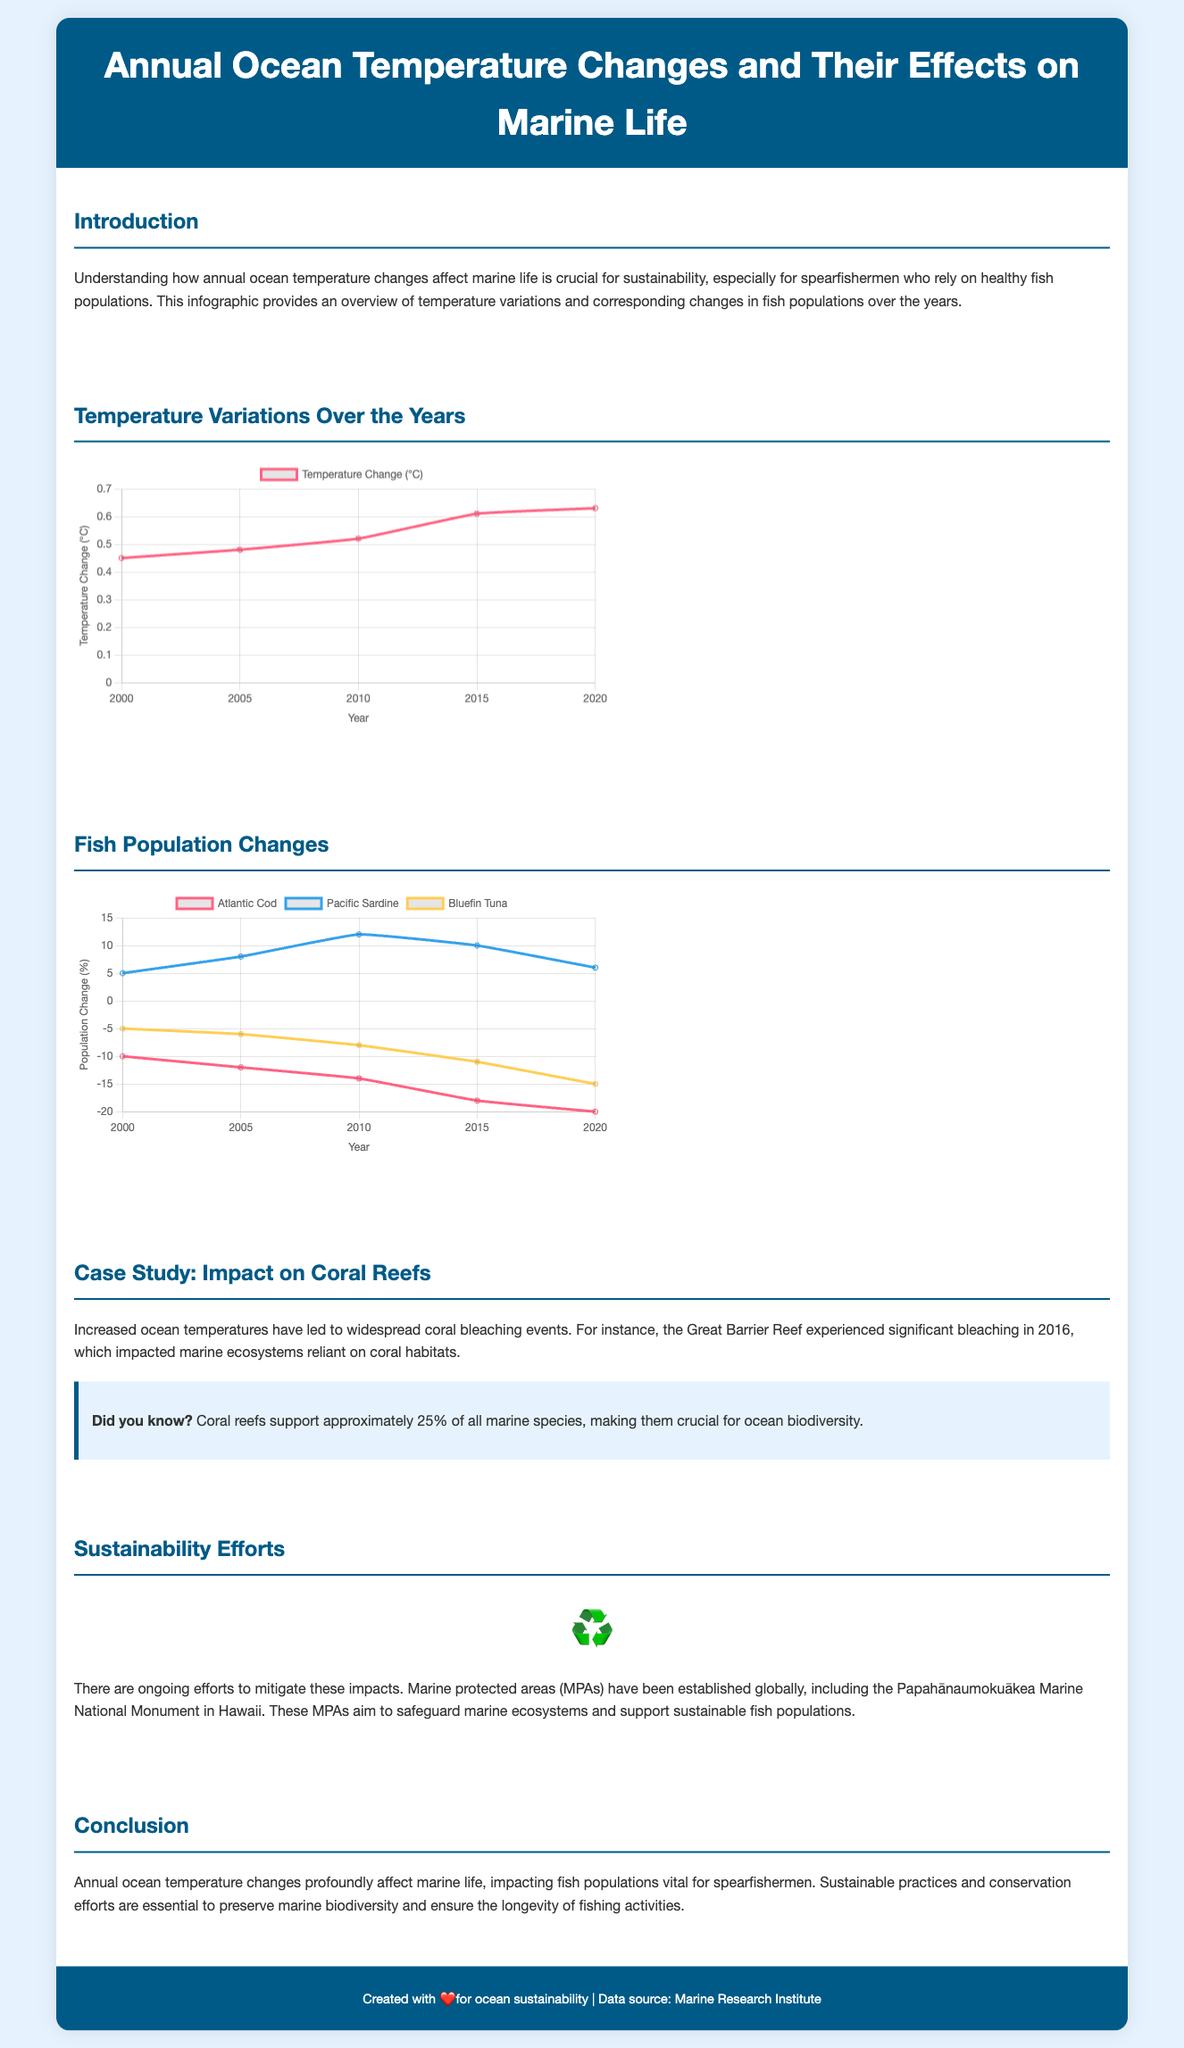What is the title of the infographic? The title of the infographic is displayed prominently at the top of the document.
Answer: Annual Ocean Temperature Changes and Their Effects on Marine Life What year experienced the highest temperature change? The temperatures are shown in a chart over a series of years, the highest value can be identified directly from the data points.
Answer: 2020 What is the fish population change for Atlantic Cod in 2020? The population changes are depicted in a chart that lists specific data points for each fish species.
Answer: -20 How many degrees Celsius did the temperature change from 2000 to 2020? The temperature changes are specified in the chart for two distinct years, the difference between the two can be calculated directly.
Answer: 0.18 Which fish species showed an increase in population from 2000 to 2010? By reviewing the population data for the various species, one can identify which species had positive growth during that time.
Answer: Pacific Sardine What is the main impact of increased ocean temperatures mentioned in the case study? The case study section describes specific events resulting from temperature changes, particularly focusing on coral reefs.
Answer: Coral bleaching What sustainability effort is highlighted in the document? The sustainability section mentions a specific initiative aimed at conserving marine ecosystems.
Answer: Marine protected areas What is the general conclusion drawn about ocean temperature changes and marine life? The conclusion summarizes the overall findings regarding the relationship between temperature changes and fish populations.
Answer: Impacting fish populations vital for spearfishermen 